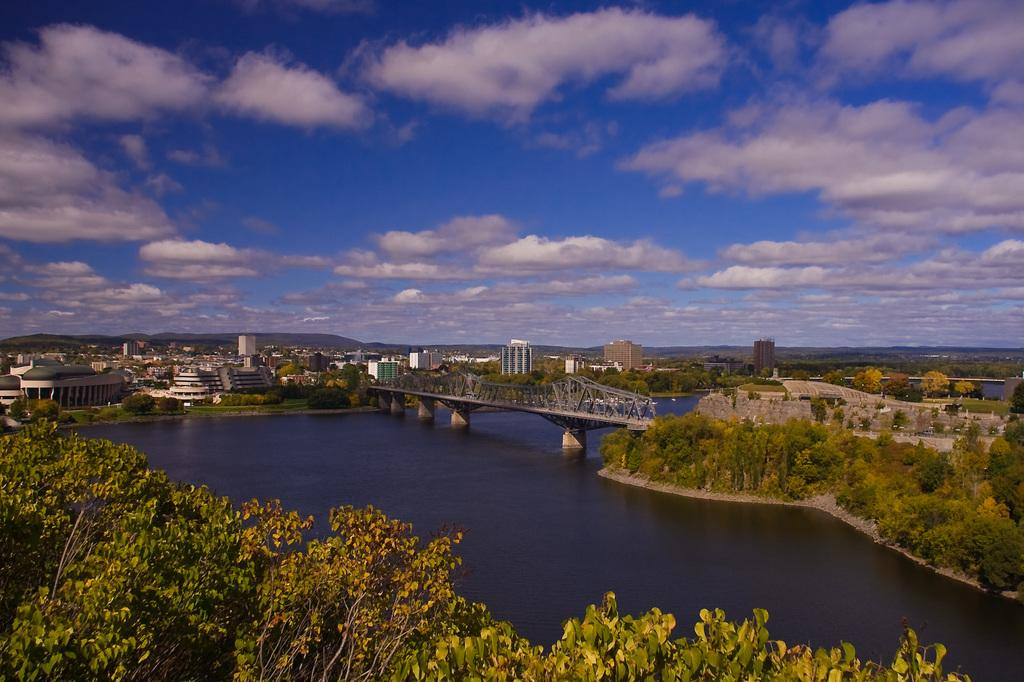What type of structure can be seen in the image? There is a bridge in the image. What natural element is visible in the image? There is water visible in the image. What type of vegetation is present in the image? There are trees in the image. What type of man-made structures can be seen in the image? There are buildings in the image. What type of geographical feature is present in the image? There are hills in the image. What is visible in the sky in the image? The sky is visible in the image, and clouds are present. What type of property is being sold in the image? There is no indication of any property being sold in the image. What type of zephyr can be seen blowing through the trees in the image? There is no zephyr present in the image; it is a still scene with no wind or breeze visible. 